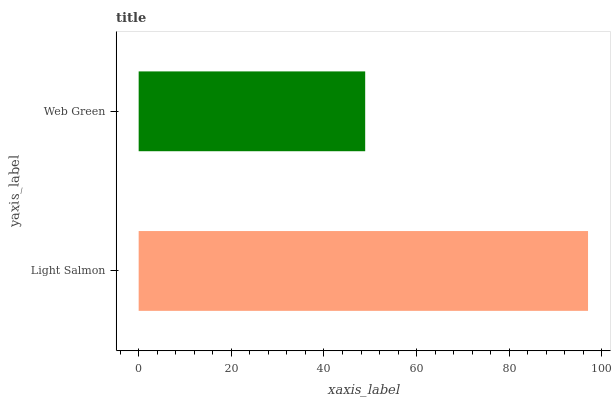Is Web Green the minimum?
Answer yes or no. Yes. Is Light Salmon the maximum?
Answer yes or no. Yes. Is Web Green the maximum?
Answer yes or no. No. Is Light Salmon greater than Web Green?
Answer yes or no. Yes. Is Web Green less than Light Salmon?
Answer yes or no. Yes. Is Web Green greater than Light Salmon?
Answer yes or no. No. Is Light Salmon less than Web Green?
Answer yes or no. No. Is Light Salmon the high median?
Answer yes or no. Yes. Is Web Green the low median?
Answer yes or no. Yes. Is Web Green the high median?
Answer yes or no. No. Is Light Salmon the low median?
Answer yes or no. No. 